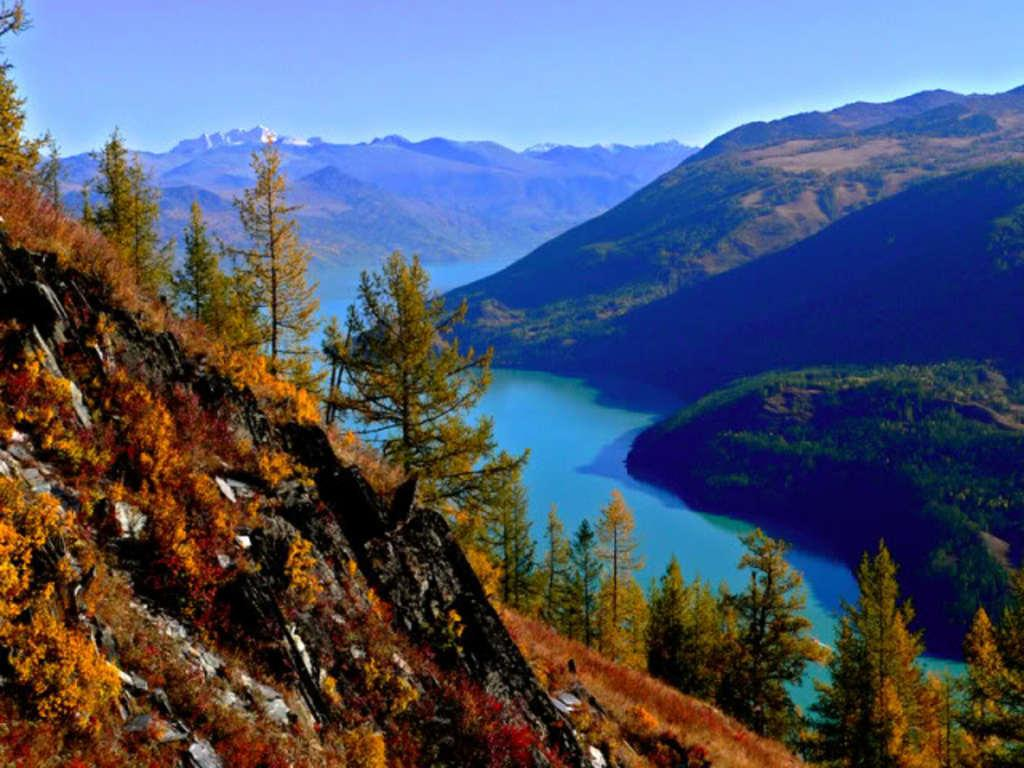What type of vegetation can be seen in the image? There are trees in the image. What natural feature is present in the image? There is water in the image. What geographical feature is visible in the image? There are mountains in the image. What is visible in the background of the image? The sky is visible in the background of the image. How many eyes can be seen on the seashore in the image? There are no eyes or seashore present in the image. What type of chair is visible in the image? There is no chair present in the image. 